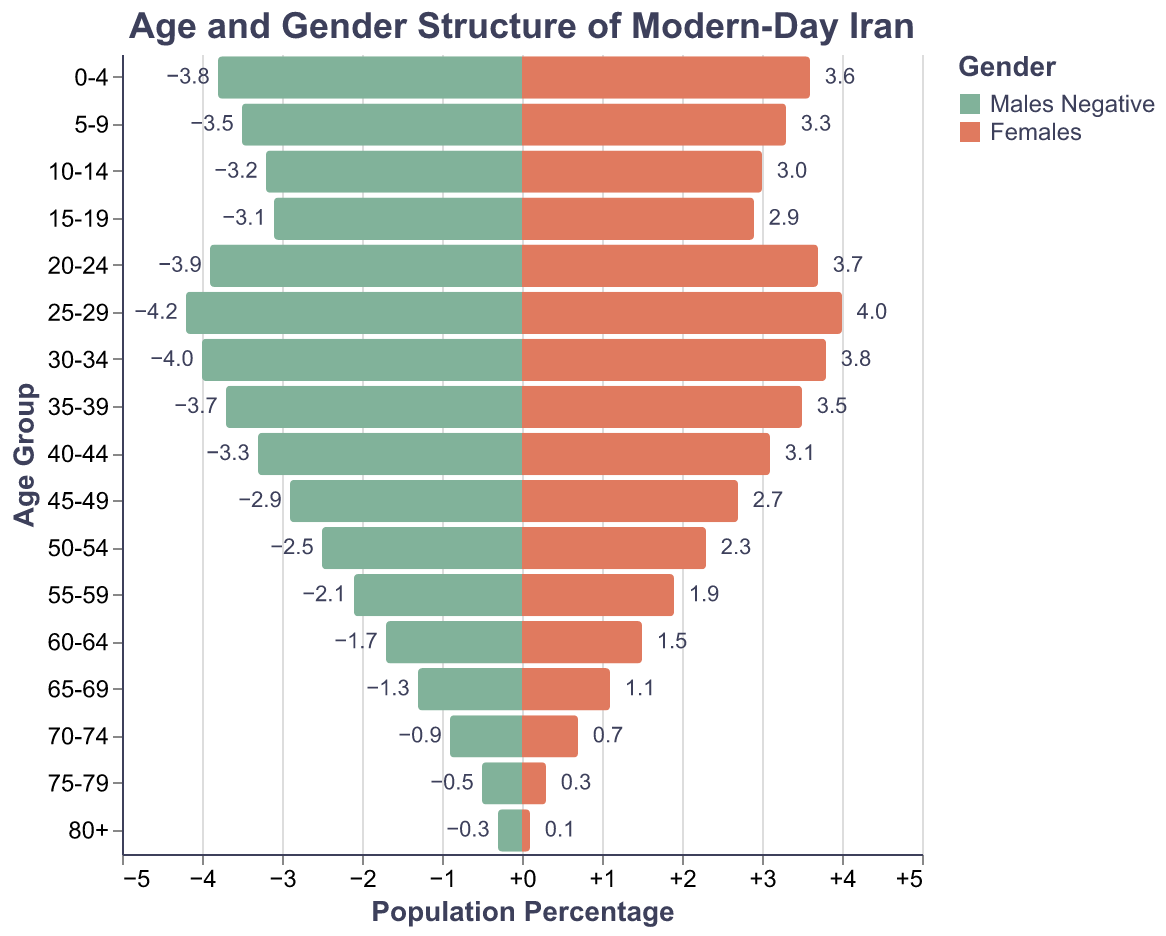What age group has the highest percentage of males? From the pyramid, the highest percentage of males is in the 25-29 age group, where the bar extends the farthest to the left.
Answer: 25-29 What is the percentage difference between males and females in the 30-34 age group? Males in the 30-34 age group have a percentage of 4.0, and females have 3.8. The difference can be calculated as 4.0 - 3.8 = 0.2.
Answer: 0.2 Which age group shows the smallest percentage for both genders? The 80+ age group has the smallest percentage for both genders, with males at 0.3% and females at 0.1%.
Answer: 80+ By how much does the percentage of males decrease from the 45-49 age group to the 50-54 age group? Males in the 45-49 age group are at 2.9%, and in the 50-54 age group, they are at 2.5%. The decrease is 2.9 - 2.5 = 0.4%.
Answer: 0.4 Compare the percentages of males and females in the 10-14 age group. Males in the 10-14 age group are at 3.2%, while females are at 3.0%. Males have a 0.2% higher percentage than females in this group.
Answer: Males 0.2% higher What is the approximate total percentage of the population aged 20-29 (both genders combined)? For males, the 20-24 group has 3.9% and the 25-29 group has 4.2%. For females, the 20-24 group has 3.7% and the 25-29 group has 4.0%. Summing these gives (3.9 + 4.2 + 3.7 + 4.0) = 15.8%.
Answer: 15.8 Is the percentage of females higher than males in any age group? If so, which group? By examining the pyramid, no age group shows a higher percentage of females compared to males; males have either equal or higher percentages in all groups.
Answer: No How does the population structure of the 0-4 age group compare between males and females? The 0-4 age group shows a 3.8% for males and 3.6% for females. Males have a 0.2% higher percentage than females.
Answer: Males 0.2% higher What trend do you observe in the population percentages as the age group increases? As age increases, there is a general trend of decreasing percentage for both genders, with higher percentages in younger age groups and much lower percentages in older groups.
Answer: Decreasing trend 